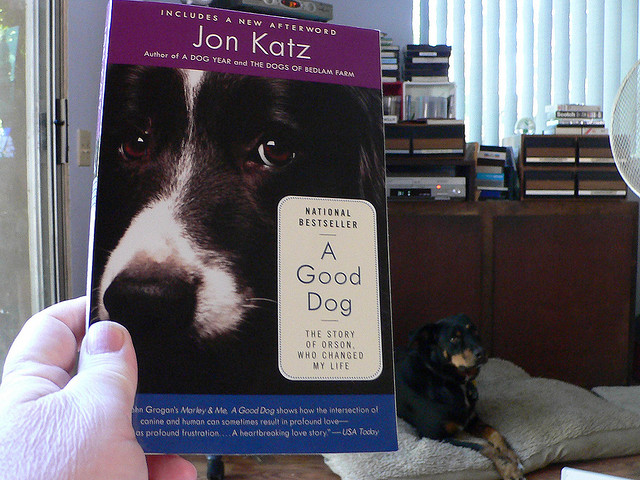How many cats with spots do you see? 0 